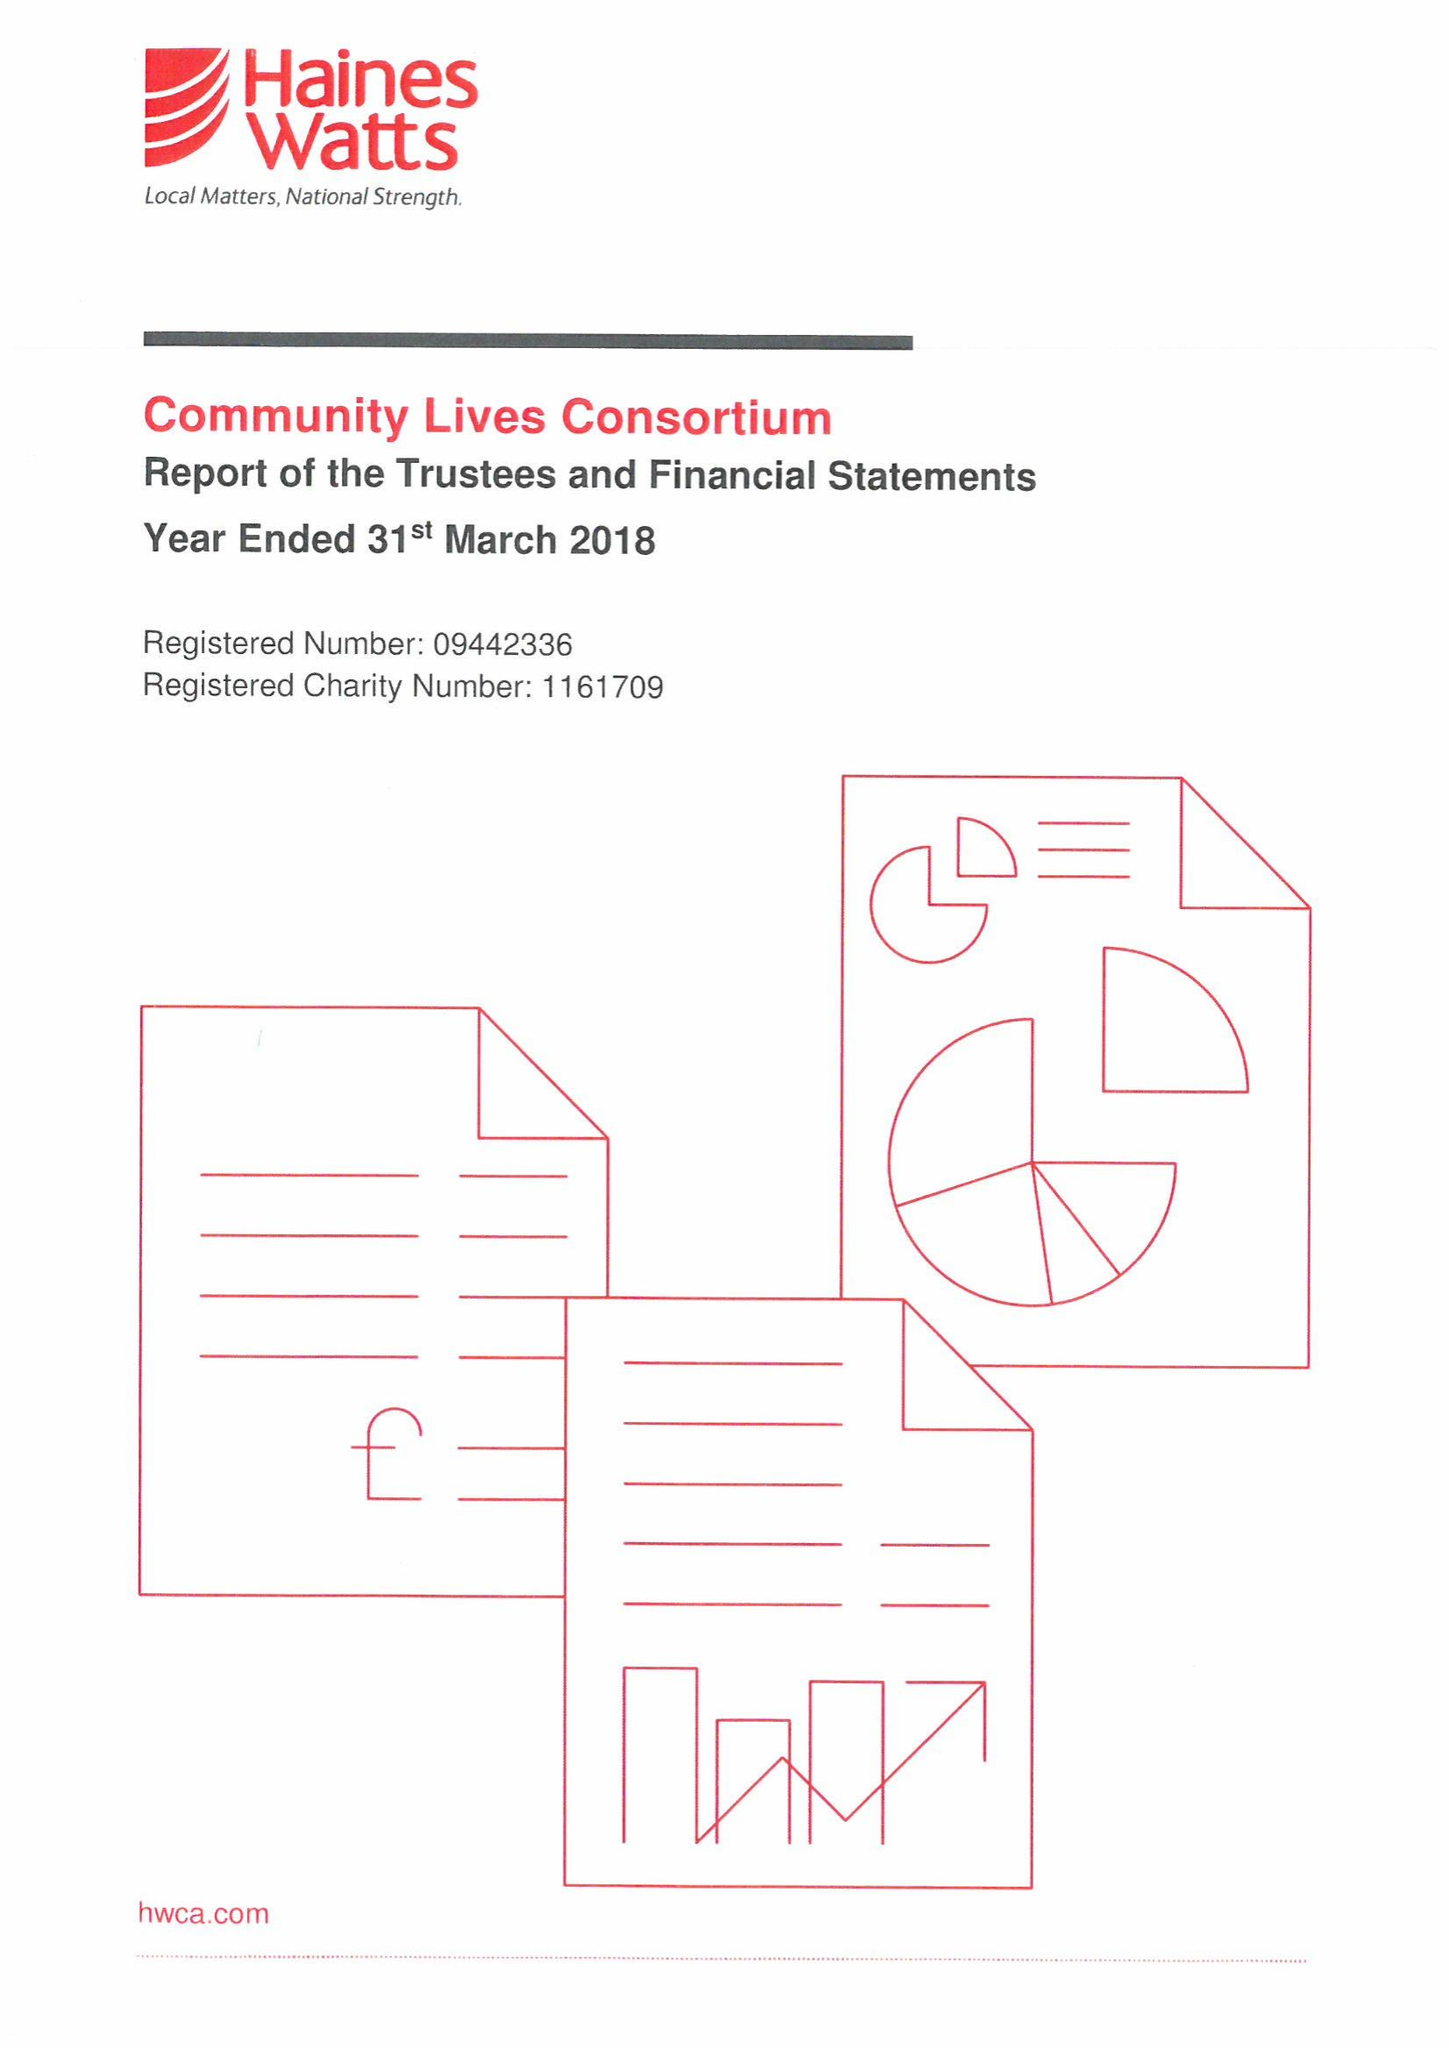What is the value for the spending_annually_in_british_pounds?
Answer the question using a single word or phrase. 16252047.00 